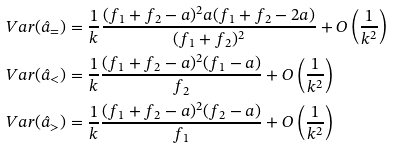Convert formula to latex. <formula><loc_0><loc_0><loc_500><loc_500>& V a r ( \hat { a } _ { = } ) = \frac { 1 } { k } \frac { ( f _ { 1 } + f _ { 2 } - a ) ^ { 2 } a ( f _ { 1 } + f _ { 2 } - 2 a ) } { ( f _ { 1 } + f _ { 2 } ) ^ { 2 } } + O \left ( \frac { 1 } { k ^ { 2 } } \right ) \\ & V a r ( \hat { a } _ { < } ) = \frac { 1 } { k } \frac { ( f _ { 1 } + f _ { 2 } - a ) ^ { 2 } ( f _ { 1 } - a ) } { f _ { 2 } } + O \left ( \frac { 1 } { k ^ { 2 } } \right ) \\ & V a r ( \hat { a } _ { > } ) = \frac { 1 } { k } \frac { ( f _ { 1 } + f _ { 2 } - a ) ^ { 2 } ( f _ { 2 } - a ) } { f _ { 1 } } + O \left ( \frac { 1 } { k ^ { 2 } } \right )</formula> 